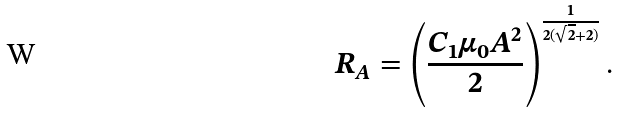<formula> <loc_0><loc_0><loc_500><loc_500>R _ { A } = \left ( \frac { C _ { 1 } \mu _ { 0 } A ^ { 2 } } { 2 } \right ) ^ { \frac { 1 } { 2 ( \sqrt { 2 } + 2 ) } } .</formula> 